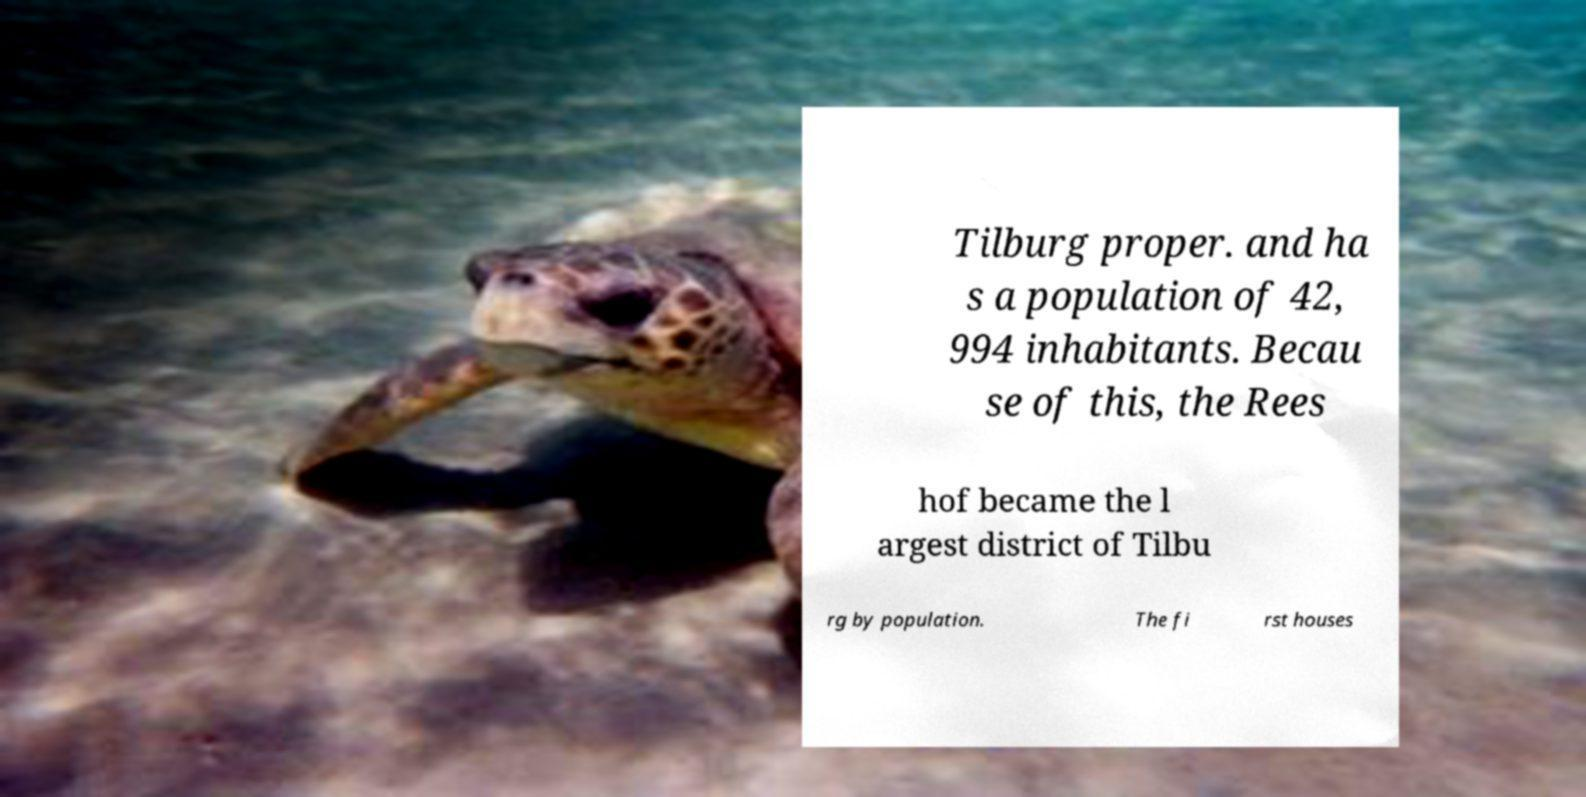What messages or text are displayed in this image? I need them in a readable, typed format. Tilburg proper. and ha s a population of 42, 994 inhabitants. Becau se of this, the Rees hof became the l argest district of Tilbu rg by population. The fi rst houses 